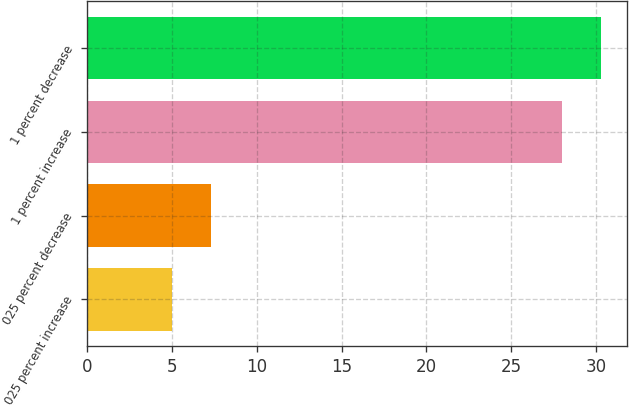<chart> <loc_0><loc_0><loc_500><loc_500><bar_chart><fcel>025 percent increase<fcel>025 percent decrease<fcel>1 percent increase<fcel>1 percent decrease<nl><fcel>5<fcel>7.3<fcel>28<fcel>30.3<nl></chart> 